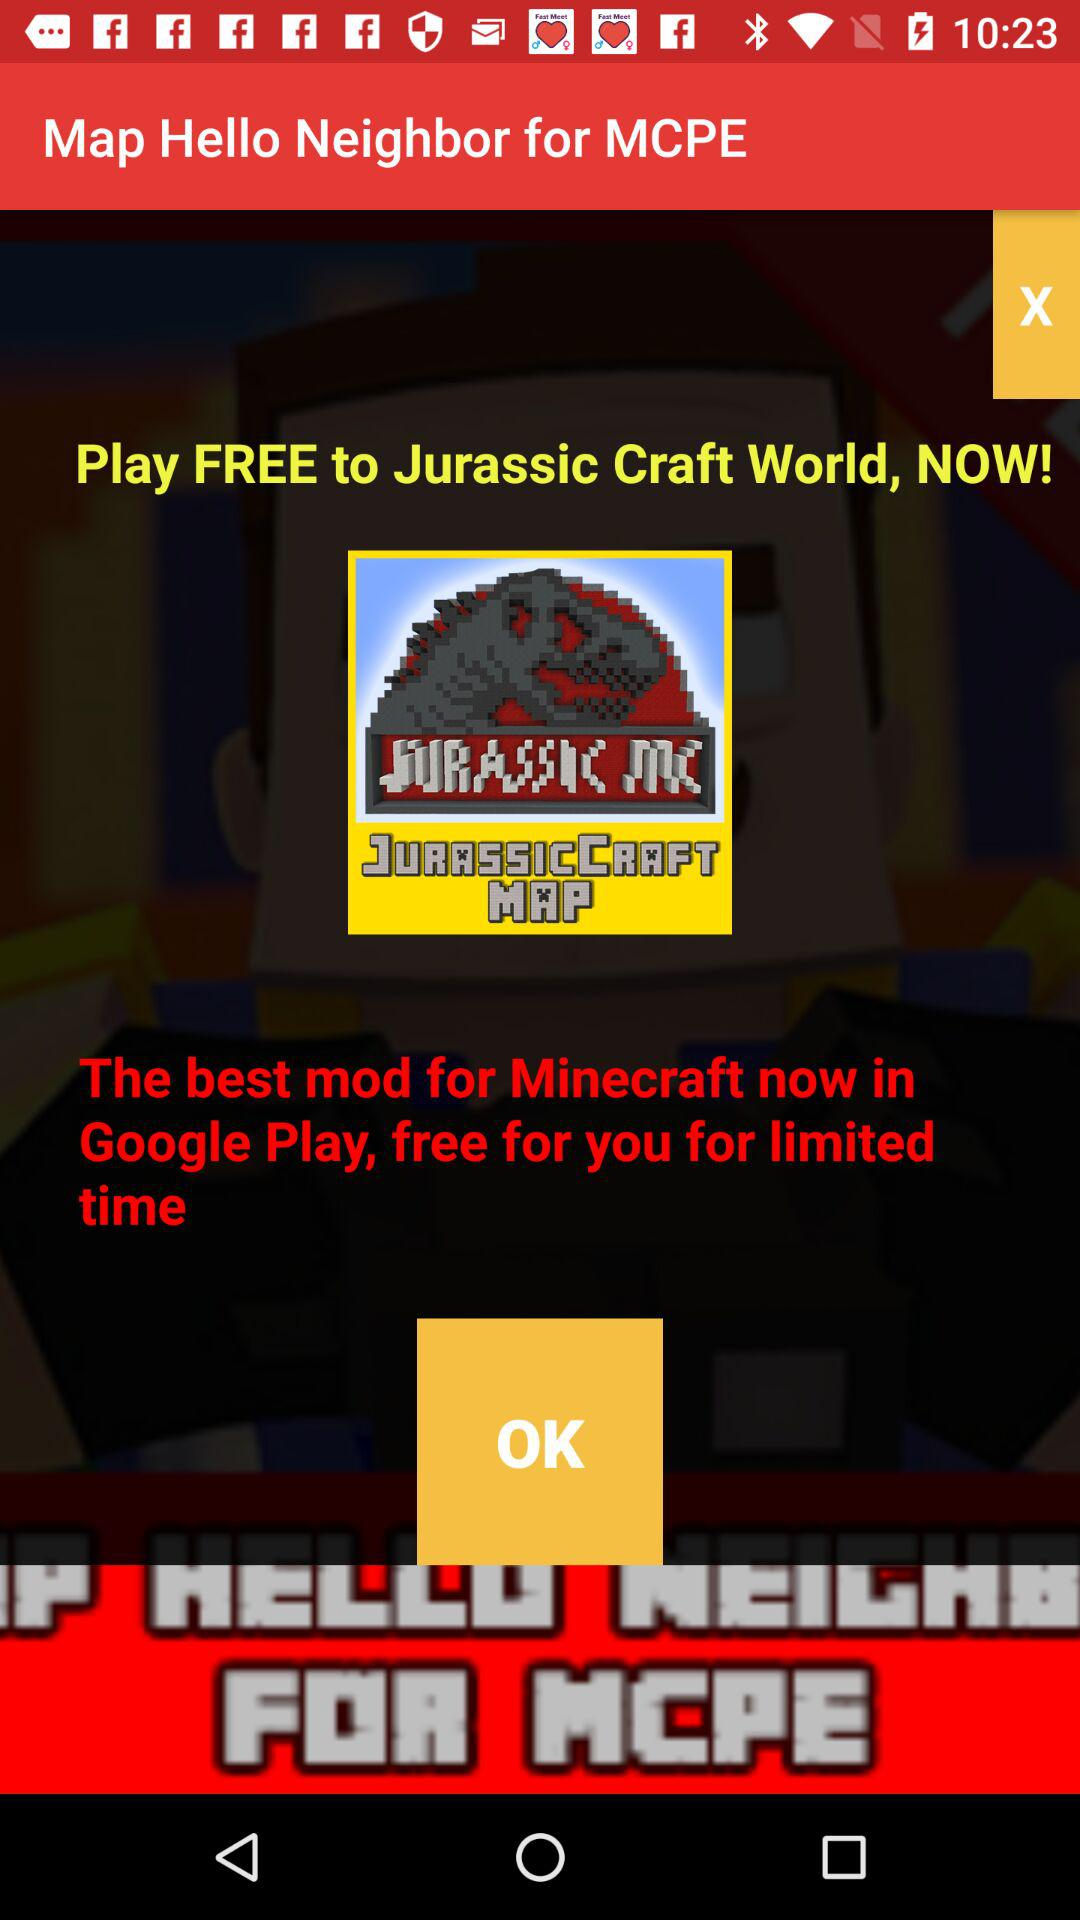What is free for a limited time on Google Play? On Google Play, the best mod for Minecraft is free for a limited time. 